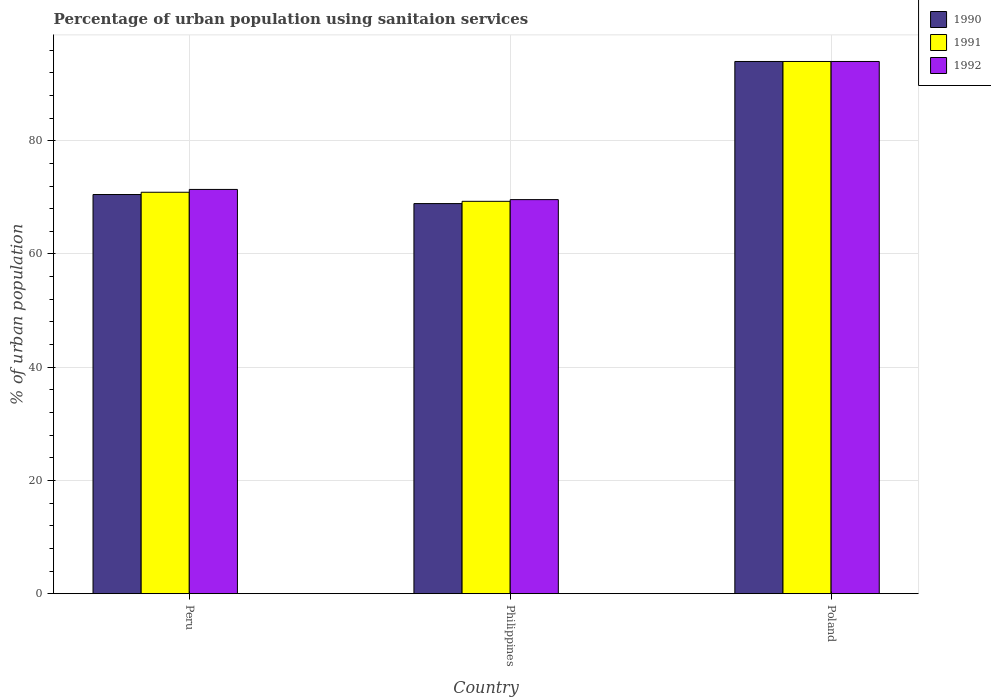How many groups of bars are there?
Offer a terse response. 3. Are the number of bars per tick equal to the number of legend labels?
Your response must be concise. Yes. Are the number of bars on each tick of the X-axis equal?
Provide a succinct answer. Yes. In how many cases, is the number of bars for a given country not equal to the number of legend labels?
Your answer should be very brief. 0. What is the percentage of urban population using sanitaion services in 1992 in Peru?
Offer a very short reply. 71.4. Across all countries, what is the maximum percentage of urban population using sanitaion services in 1991?
Your answer should be compact. 94. Across all countries, what is the minimum percentage of urban population using sanitaion services in 1990?
Offer a very short reply. 68.9. In which country was the percentage of urban population using sanitaion services in 1990 maximum?
Your answer should be very brief. Poland. In which country was the percentage of urban population using sanitaion services in 1991 minimum?
Your response must be concise. Philippines. What is the total percentage of urban population using sanitaion services in 1992 in the graph?
Offer a terse response. 235. What is the difference between the percentage of urban population using sanitaion services in 1992 in Peru and that in Philippines?
Make the answer very short. 1.8. What is the difference between the percentage of urban population using sanitaion services in 1991 in Philippines and the percentage of urban population using sanitaion services in 1992 in Peru?
Your answer should be very brief. -2.1. What is the average percentage of urban population using sanitaion services in 1991 per country?
Keep it short and to the point. 78.07. What is the difference between the percentage of urban population using sanitaion services of/in 1990 and percentage of urban population using sanitaion services of/in 1991 in Poland?
Make the answer very short. 0. What is the ratio of the percentage of urban population using sanitaion services in 1991 in Peru to that in Poland?
Provide a succinct answer. 0.75. Is the percentage of urban population using sanitaion services in 1991 in Peru less than that in Poland?
Ensure brevity in your answer.  Yes. What is the difference between the highest and the second highest percentage of urban population using sanitaion services in 1992?
Your response must be concise. -24.4. What is the difference between the highest and the lowest percentage of urban population using sanitaion services in 1992?
Offer a terse response. 24.4. What does the 2nd bar from the left in Poland represents?
Ensure brevity in your answer.  1991. Are all the bars in the graph horizontal?
Ensure brevity in your answer.  No. What is the difference between two consecutive major ticks on the Y-axis?
Make the answer very short. 20. Are the values on the major ticks of Y-axis written in scientific E-notation?
Your answer should be very brief. No. Does the graph contain any zero values?
Keep it short and to the point. No. What is the title of the graph?
Provide a short and direct response. Percentage of urban population using sanitaion services. What is the label or title of the X-axis?
Give a very brief answer. Country. What is the label or title of the Y-axis?
Give a very brief answer. % of urban population. What is the % of urban population of 1990 in Peru?
Ensure brevity in your answer.  70.5. What is the % of urban population of 1991 in Peru?
Your answer should be very brief. 70.9. What is the % of urban population of 1992 in Peru?
Ensure brevity in your answer.  71.4. What is the % of urban population in 1990 in Philippines?
Ensure brevity in your answer.  68.9. What is the % of urban population of 1991 in Philippines?
Your answer should be very brief. 69.3. What is the % of urban population of 1992 in Philippines?
Give a very brief answer. 69.6. What is the % of urban population of 1990 in Poland?
Offer a terse response. 94. What is the % of urban population in 1991 in Poland?
Your response must be concise. 94. What is the % of urban population in 1992 in Poland?
Your answer should be compact. 94. Across all countries, what is the maximum % of urban population in 1990?
Provide a short and direct response. 94. Across all countries, what is the maximum % of urban population in 1991?
Keep it short and to the point. 94. Across all countries, what is the maximum % of urban population of 1992?
Your response must be concise. 94. Across all countries, what is the minimum % of urban population of 1990?
Make the answer very short. 68.9. Across all countries, what is the minimum % of urban population of 1991?
Make the answer very short. 69.3. Across all countries, what is the minimum % of urban population of 1992?
Offer a very short reply. 69.6. What is the total % of urban population of 1990 in the graph?
Provide a succinct answer. 233.4. What is the total % of urban population of 1991 in the graph?
Offer a very short reply. 234.2. What is the total % of urban population in 1992 in the graph?
Provide a short and direct response. 235. What is the difference between the % of urban population in 1990 in Peru and that in Philippines?
Provide a short and direct response. 1.6. What is the difference between the % of urban population of 1991 in Peru and that in Philippines?
Keep it short and to the point. 1.6. What is the difference between the % of urban population of 1990 in Peru and that in Poland?
Keep it short and to the point. -23.5. What is the difference between the % of urban population of 1991 in Peru and that in Poland?
Your answer should be compact. -23.1. What is the difference between the % of urban population in 1992 in Peru and that in Poland?
Offer a very short reply. -22.6. What is the difference between the % of urban population of 1990 in Philippines and that in Poland?
Provide a succinct answer. -25.1. What is the difference between the % of urban population of 1991 in Philippines and that in Poland?
Your answer should be very brief. -24.7. What is the difference between the % of urban population of 1992 in Philippines and that in Poland?
Your answer should be very brief. -24.4. What is the difference between the % of urban population in 1990 in Peru and the % of urban population in 1991 in Philippines?
Provide a succinct answer. 1.2. What is the difference between the % of urban population of 1990 in Peru and the % of urban population of 1991 in Poland?
Ensure brevity in your answer.  -23.5. What is the difference between the % of urban population in 1990 in Peru and the % of urban population in 1992 in Poland?
Make the answer very short. -23.5. What is the difference between the % of urban population in 1991 in Peru and the % of urban population in 1992 in Poland?
Your answer should be very brief. -23.1. What is the difference between the % of urban population of 1990 in Philippines and the % of urban population of 1991 in Poland?
Provide a short and direct response. -25.1. What is the difference between the % of urban population of 1990 in Philippines and the % of urban population of 1992 in Poland?
Give a very brief answer. -25.1. What is the difference between the % of urban population of 1991 in Philippines and the % of urban population of 1992 in Poland?
Make the answer very short. -24.7. What is the average % of urban population in 1990 per country?
Provide a short and direct response. 77.8. What is the average % of urban population of 1991 per country?
Your response must be concise. 78.07. What is the average % of urban population in 1992 per country?
Provide a succinct answer. 78.33. What is the difference between the % of urban population of 1991 and % of urban population of 1992 in Peru?
Offer a terse response. -0.5. What is the difference between the % of urban population of 1991 and % of urban population of 1992 in Philippines?
Your answer should be very brief. -0.3. What is the difference between the % of urban population of 1990 and % of urban population of 1991 in Poland?
Make the answer very short. 0. What is the ratio of the % of urban population of 1990 in Peru to that in Philippines?
Make the answer very short. 1.02. What is the ratio of the % of urban population in 1991 in Peru to that in Philippines?
Your answer should be compact. 1.02. What is the ratio of the % of urban population in 1992 in Peru to that in Philippines?
Offer a terse response. 1.03. What is the ratio of the % of urban population in 1991 in Peru to that in Poland?
Provide a succinct answer. 0.75. What is the ratio of the % of urban population in 1992 in Peru to that in Poland?
Offer a terse response. 0.76. What is the ratio of the % of urban population in 1990 in Philippines to that in Poland?
Make the answer very short. 0.73. What is the ratio of the % of urban population in 1991 in Philippines to that in Poland?
Your answer should be very brief. 0.74. What is the ratio of the % of urban population of 1992 in Philippines to that in Poland?
Provide a succinct answer. 0.74. What is the difference between the highest and the second highest % of urban population of 1991?
Make the answer very short. 23.1. What is the difference between the highest and the second highest % of urban population of 1992?
Your response must be concise. 22.6. What is the difference between the highest and the lowest % of urban population in 1990?
Make the answer very short. 25.1. What is the difference between the highest and the lowest % of urban population in 1991?
Provide a short and direct response. 24.7. What is the difference between the highest and the lowest % of urban population in 1992?
Make the answer very short. 24.4. 